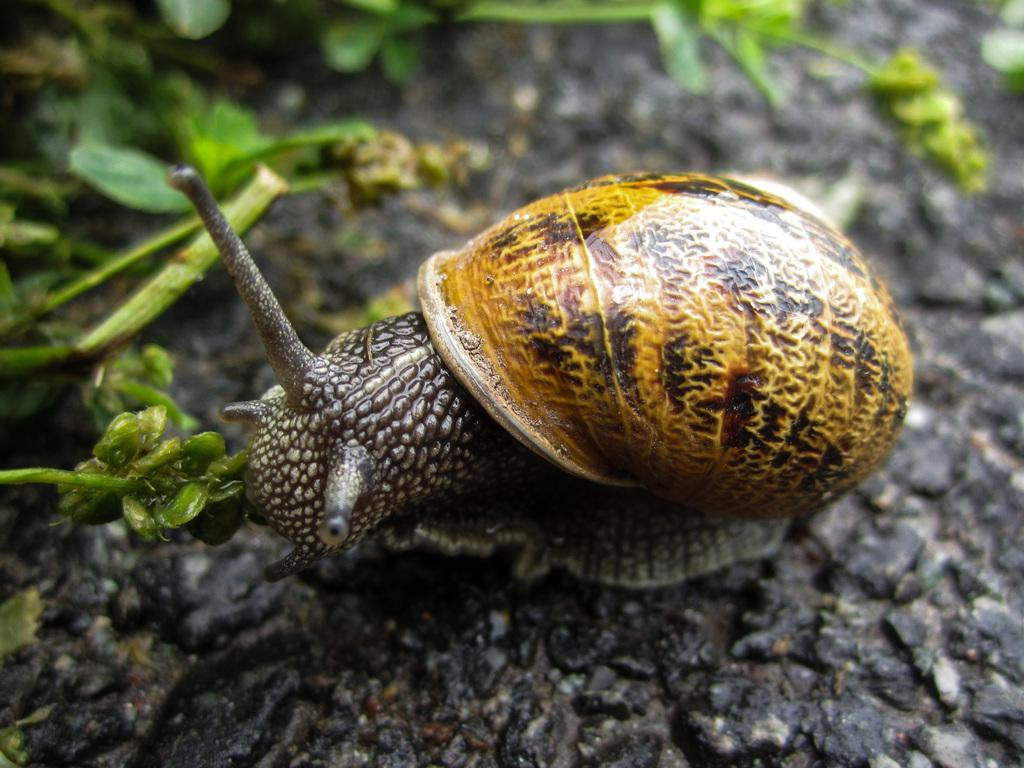What is the main subject in the middle of the image? There is a snail in the middle of the image. What else can be seen in the image besides the snail? Plants are visible in the image. What type of lock can be seen on the snail's mind in the image? There is no lock or reference to a snail's mind in the image; it only features a snail and plants. 